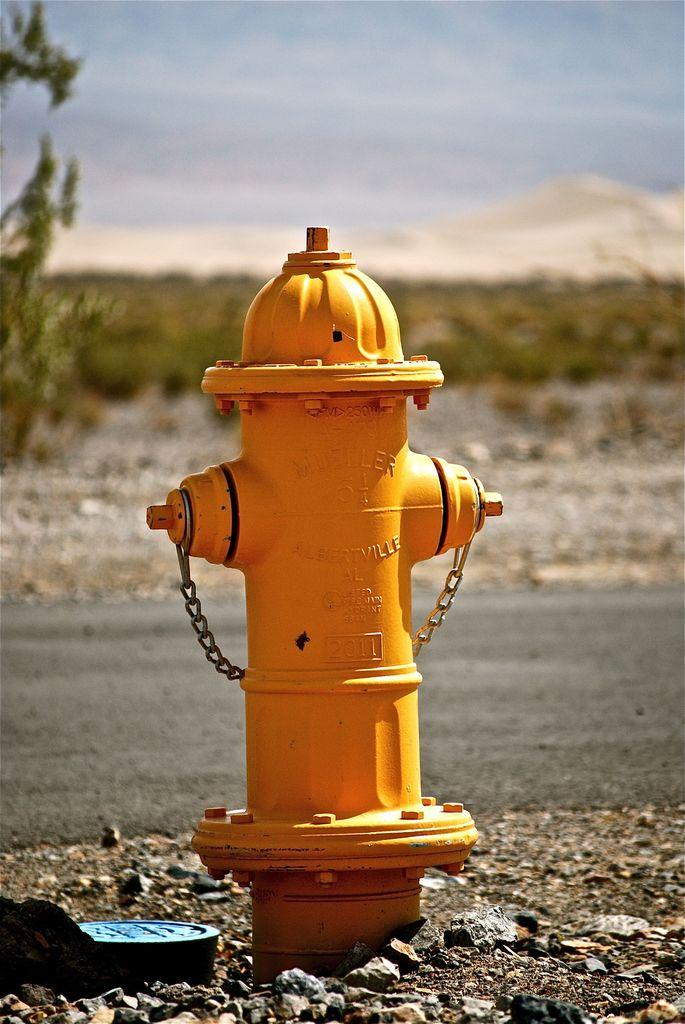What color is the fire hydrant in the image? The fire hydrant in the fire hydrant in the image is yellow. Where is the fire hydrant located? The fire hydrant is on a path in the image. What can be seen behind the fire hydrant? There is a path visible behind the fire hydrant. What is visible in the background of the image? Trees and the sky are visible in the background of the image. How many times does the fire hydrant sneeze in the image? Fire hydrants do not sneeze, as they are inanimate objects. 